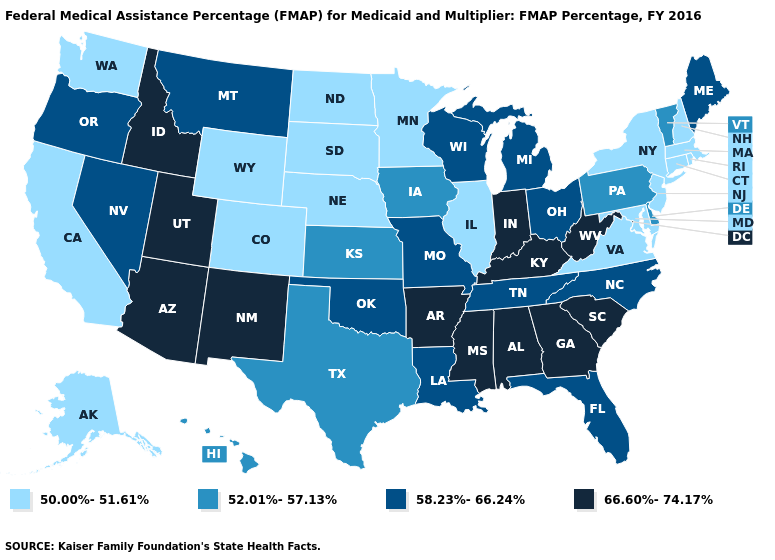What is the value of Alaska?
Concise answer only. 50.00%-51.61%. Name the states that have a value in the range 50.00%-51.61%?
Keep it brief. Alaska, California, Colorado, Connecticut, Illinois, Maryland, Massachusetts, Minnesota, Nebraska, New Hampshire, New Jersey, New York, North Dakota, Rhode Island, South Dakota, Virginia, Washington, Wyoming. Name the states that have a value in the range 52.01%-57.13%?
Write a very short answer. Delaware, Hawaii, Iowa, Kansas, Pennsylvania, Texas, Vermont. Name the states that have a value in the range 52.01%-57.13%?
Quick response, please. Delaware, Hawaii, Iowa, Kansas, Pennsylvania, Texas, Vermont. What is the value of Oregon?
Keep it brief. 58.23%-66.24%. What is the value of Massachusetts?
Quick response, please. 50.00%-51.61%. Does the first symbol in the legend represent the smallest category?
Concise answer only. Yes. Among the states that border Wisconsin , does Iowa have the lowest value?
Be succinct. No. What is the value of Wyoming?
Keep it brief. 50.00%-51.61%. Does Delaware have a higher value than Kansas?
Quick response, please. No. What is the lowest value in the MidWest?
Answer briefly. 50.00%-51.61%. What is the lowest value in the USA?
Keep it brief. 50.00%-51.61%. Does Oregon have the highest value in the West?
Quick response, please. No. Among the states that border Pennsylvania , which have the highest value?
Keep it brief. West Virginia. Does Florida have the highest value in the USA?
Write a very short answer. No. 